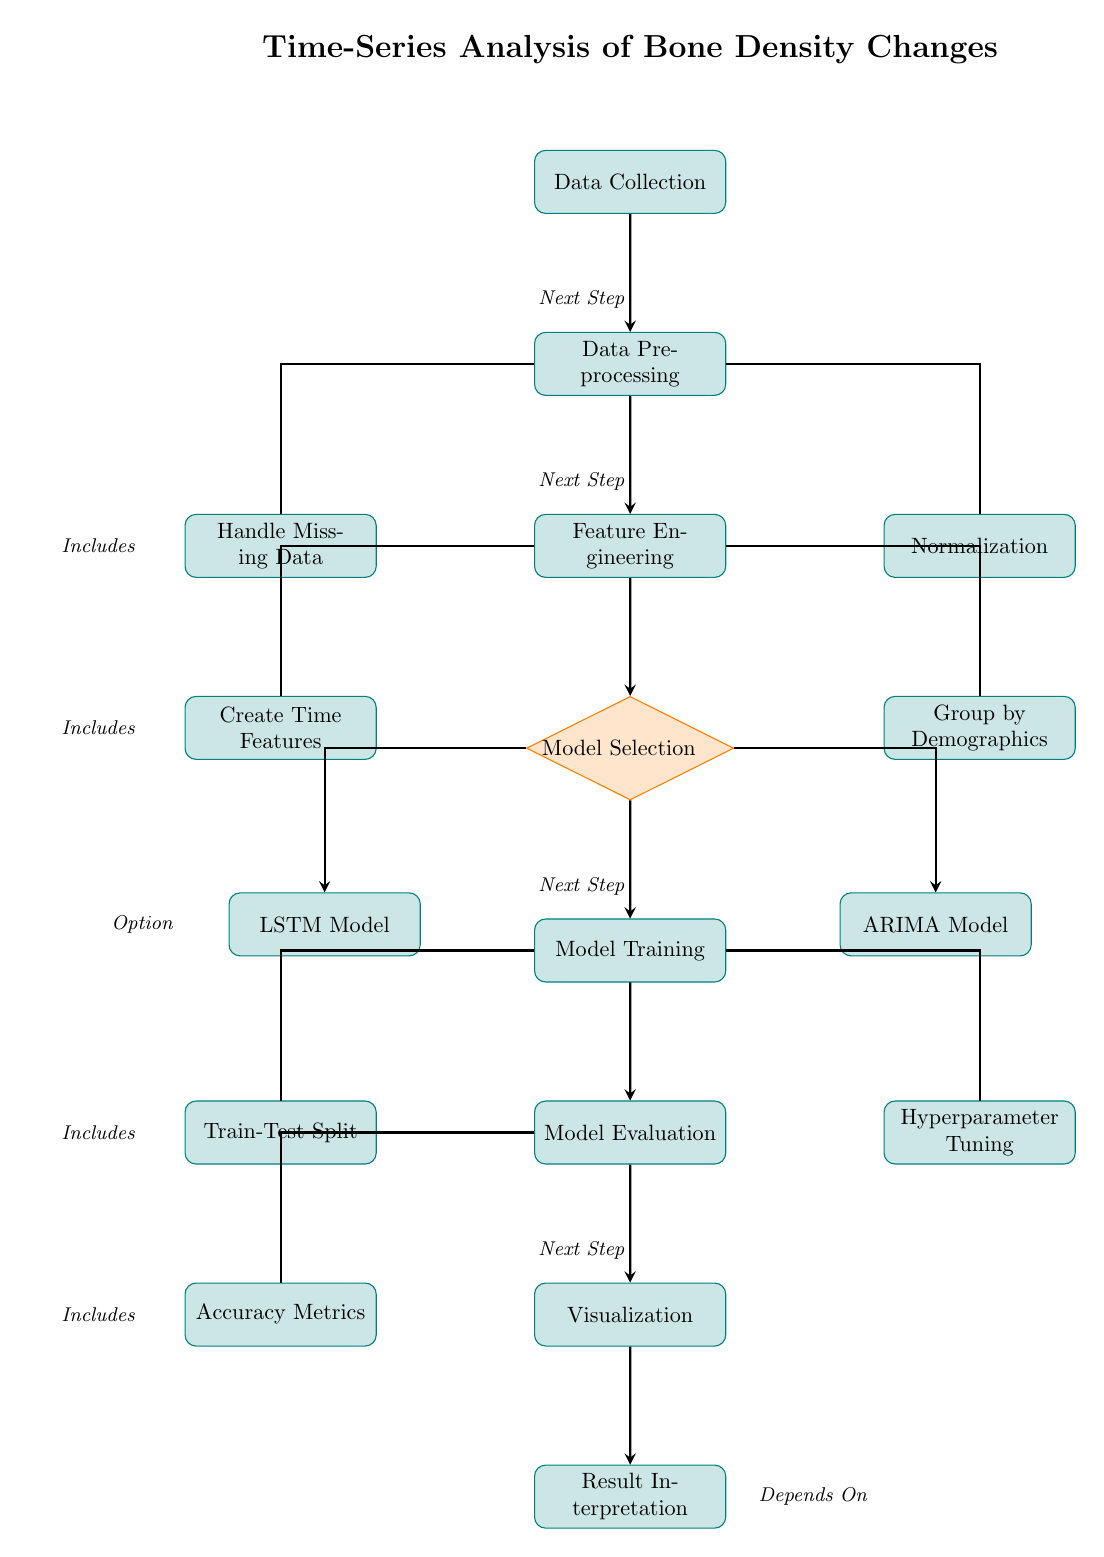What is the first step in the diagram? The first step in the diagram is represented in the topmost node labeled "Data Collection". This node is the starting point for the entire machine learning process.
Answer: Data Collection How many processes are represented in the diagram? By counting all nodes that fall under the "process" style, we see that there are eleven distinct processes in the diagram.
Answer: Eleven Which node follows "Data Preprocessing"? The node that immediately follows "Data Preprocessing" is labeled "Feature Engineering". This flows directly down from the preprocessing stage.
Answer: Feature Engineering What do you do after "Model Evaluation"? After "Model Evaluation", the next step indicated in the diagram is "Visualization". This indicates that visualization is a key follow-up to evaluation.
Answer: Visualization Which two models are selected during the "Model Selection" step? The two models selected during the "Model Selection" step are "LSTM Model" and "ARIMA Model". Both models branch from the selection process node.
Answer: LSTM Model and ARIMA Model How is "Train-Test Split" related to "Model Training"? "Train-Test Split" is a sub-process that occurs during "Model Training". The arrow indicates that it is part of the model training workflow.
Answer: It is a sub-process What are the ultimate outcomes of the "Model Evaluation"? The outcomes of "Model Evaluation" are captured in two subsequent processes directly connected to it: "Accuracy Metrics" and "Visualization". This indicates that these are the main focuses after assessment.
Answer: Accuracy Metrics and Visualization Where does the "Normalization" step branch from? The "Normalization" step branches from the "Data Preprocessing" node. This is evident from the layout, where normalization is a crucial aspect of preprocessing data.
Answer: Data Preprocessing What is the decision-making node in this diagram? The decision-making node in the diagram is "Model Selection". This diamond-shaped node signifies a pivotal choice point in the analysis process.
Answer: Model Selection What is the last step in the process depicted in the diagram? The last step in the process is labeled "Result Interpretation", which stands as the final action taken after visualizing the results.
Answer: Result Interpretation 